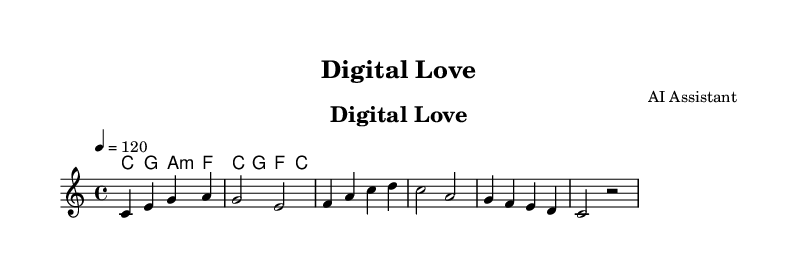What is the key signature of this music? The key signature is C major, which contains no sharps or flats indicated in the music notation.
Answer: C major What is the time signature of this music? The time signature is indicated as 4/4, showing that there are four beats in each measure.
Answer: 4/4 What is the tempo of the piece? The tempo marking shows "4 = 120," indicating the quarter note equals 120 beats per minute.
Answer: 120 How many measures are in the melody? The melody has a total of six measures, identifiable by counting the segments separated by vertical lines.
Answer: 6 What are the first three notes of the melody? The first three notes of the melody starting from the beginning are C, E, and G, clearly notated at the start of the score.
Answer: C E G What is the dynamic for the harmony chords? There is no dynamic marking shown above the harmony chords, suggesting a standard dynamic level unless specified otherwise.
Answer: None What is the primary theme of the lyrics? The lyrics reference modern digital interactions and relationships, highlighting technology's impact on love and connection.
Answer: Digital interactions 